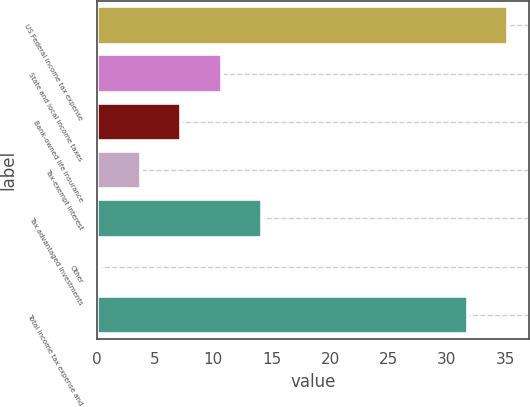Convert chart to OTSL. <chart><loc_0><loc_0><loc_500><loc_500><bar_chart><fcel>US Federal income tax expense<fcel>State and local income taxes<fcel>Bank-owned life insurance<fcel>Tax-exempt interest<fcel>Tax advantaged investments<fcel>Other<fcel>Total income tax expense and<nl><fcel>35.27<fcel>10.71<fcel>7.24<fcel>3.77<fcel>14.18<fcel>0.3<fcel>31.8<nl></chart> 